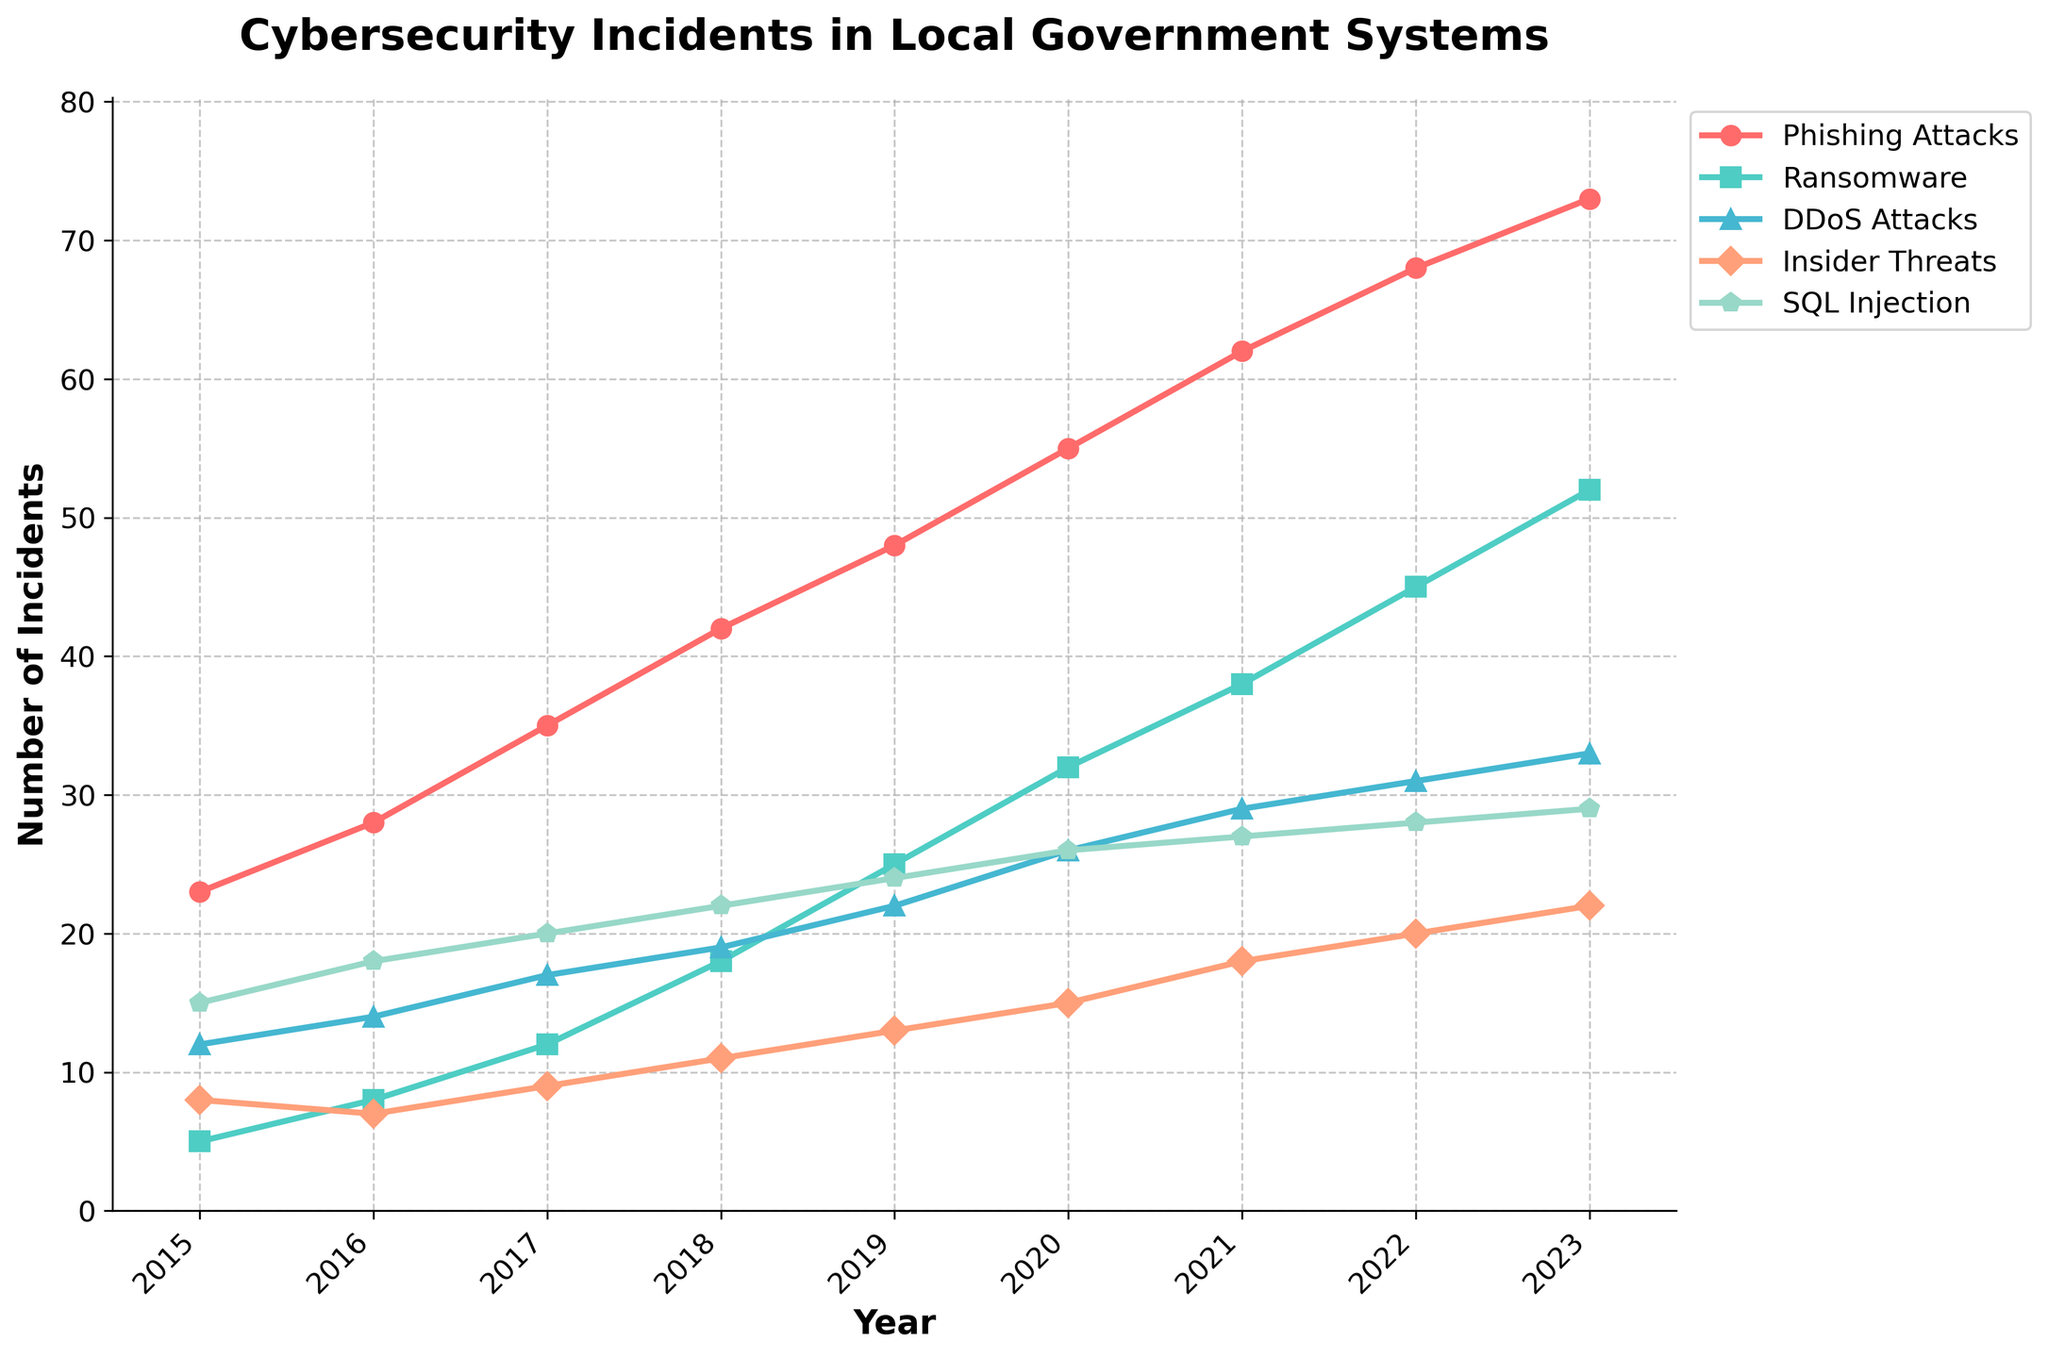Which type of attack saw the highest increase in incidents from 2015 to 2023? To determine this, calculate the difference in the number of incidents for each type of attack between 2015 and 2023. The increases are as follows: Phishing Attacks (73-23=50), Ransomware (52-5=47), DDoS Attacks (33-12=21), Insider Threats (22-8=14), SQL Injection (29-15=14). Phishing Attacks saw the highest increase in incidents.
Answer: Phishing Attacks How did the number of ransomware attacks change between 2018 and 2020? Look at the number of ransomware attacks in 2018 and 2020. In 2018, there were 18 incidents, and in 2020, there were 32 incidents. The change is 32 - 18 = 14.
Answer: Increased by 14 In which year did DDoS attacks pass 20 incidents? By observing the values over the years, DDoS attacks surpassed 20 incidents in the year 2019 with 22 incidents.
Answer: 2019 Which type of attack had the least incidents in 2019? Review the number of incidents in 2019 for each attack type. In 2019, Phishing Attacks (48), Ransomware (25), DDoS Attacks (22), Insider Threats (13), SQL Injection (24). Insider Threats had the least incidents.
Answer: Insider Threats What was the average number of SQL Injection incidents from 2015 to 2023? To calculate the average, sum the number of SQL Injection incidents from 2015 to 2023 and divide by 9. The sum is 15+18+20+22+24+26+27+28+29=209. The average is 209/9 ≈ 23.2.
Answer: 23.2 In which year were the total number of incidents across all attack types the highest? Sum the incidents for all attack types for each year and identify the highest. For 2023: 73+52+33+22+29=209, which is the highest across all years.
Answer: 2023 How many more Phishing Attacks were recorded in 2023 compared to 2016? Subtract the number of Phishing Attacks in 2016 from those in 2023; 73 - 28 = 45.
Answer: 45 more Which attack type shows the second most incidents in 2022? Review the number of incidents for each attack type in 2022. Phishing Attacks (68), Ransomware (45), DDoS Attacks (31), Insider Threats (20), SQL Injection (28). Ransomware shows the second most incidents.
Answer: Ransomware From 2015 to 2023, which attack type consistently increased every year? Check the trend for each attack type across all the years. Phishing Attacks, Ransomware, and DDoS Attacks consistently increase every year. Since we are looking for one type, Phishing Attacks had the most distinguishable growth.
Answer: Phishing Attacks 